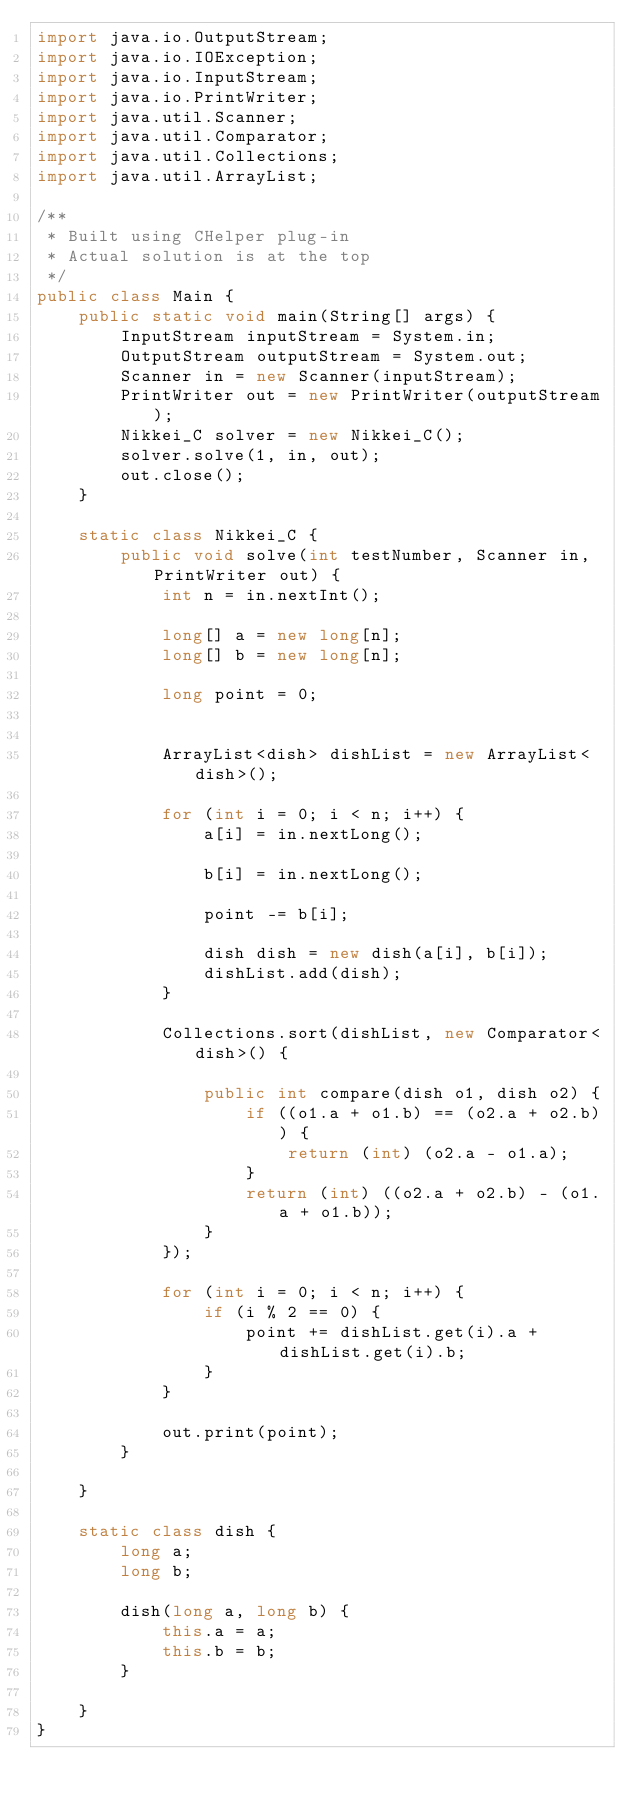<code> <loc_0><loc_0><loc_500><loc_500><_Java_>import java.io.OutputStream;
import java.io.IOException;
import java.io.InputStream;
import java.io.PrintWriter;
import java.util.Scanner;
import java.util.Comparator;
import java.util.Collections;
import java.util.ArrayList;

/**
 * Built using CHelper plug-in
 * Actual solution is at the top
 */
public class Main {
    public static void main(String[] args) {
        InputStream inputStream = System.in;
        OutputStream outputStream = System.out;
        Scanner in = new Scanner(inputStream);
        PrintWriter out = new PrintWriter(outputStream);
        Nikkei_C solver = new Nikkei_C();
        solver.solve(1, in, out);
        out.close();
    }

    static class Nikkei_C {
        public void solve(int testNumber, Scanner in, PrintWriter out) {
            int n = in.nextInt();

            long[] a = new long[n];
            long[] b = new long[n];

            long point = 0;


            ArrayList<dish> dishList = new ArrayList<dish>();

            for (int i = 0; i < n; i++) {
                a[i] = in.nextLong();

                b[i] = in.nextLong();

                point -= b[i];

                dish dish = new dish(a[i], b[i]);
                dishList.add(dish);
            }

            Collections.sort(dishList, new Comparator<dish>() {

                public int compare(dish o1, dish o2) {
                    if ((o1.a + o1.b) == (o2.a + o2.b)) {
                        return (int) (o2.a - o1.a);
                    }
                    return (int) ((o2.a + o2.b) - (o1.a + o1.b));
                }
            });

            for (int i = 0; i < n; i++) {
                if (i % 2 == 0) {
                    point += dishList.get(i).a + dishList.get(i).b;
                }
            }

            out.print(point);
        }

    }

    static class dish {
        long a;
        long b;

        dish(long a, long b) {
            this.a = a;
            this.b = b;
        }

    }
}

</code> 